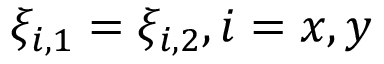<formula> <loc_0><loc_0><loc_500><loc_500>\xi _ { i , 1 } = \xi _ { i , 2 } , i = x , y</formula> 